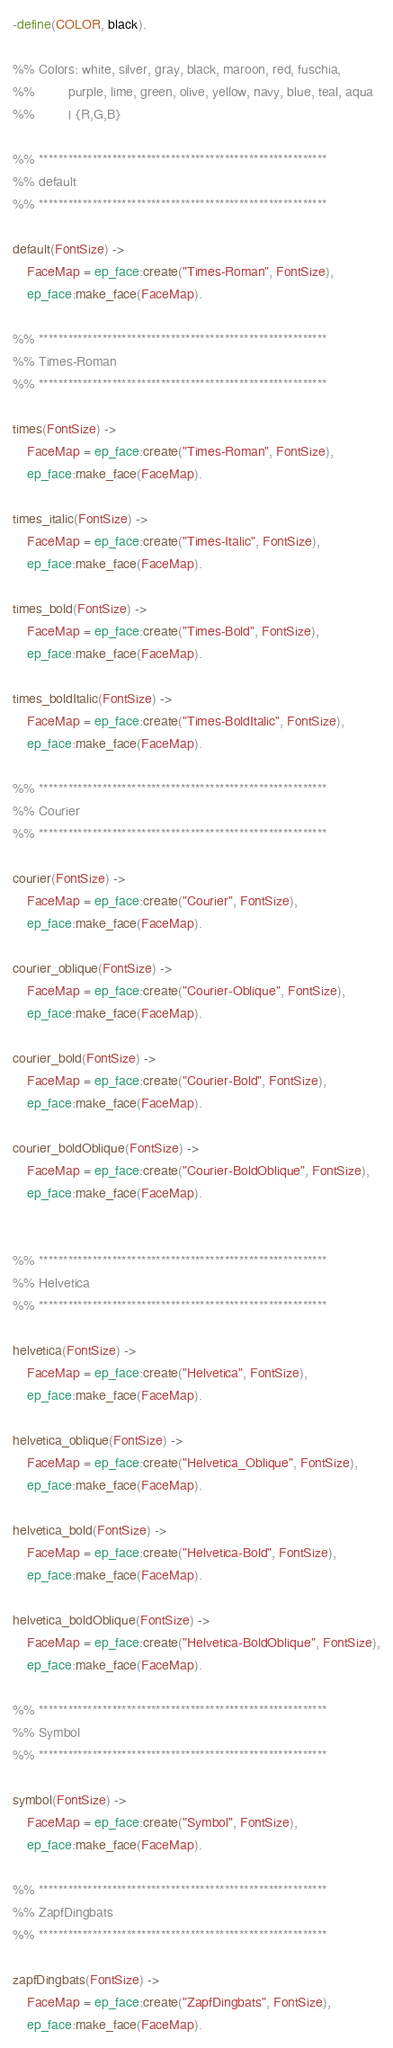Convert code to text. <code><loc_0><loc_0><loc_500><loc_500><_Erlang_>-define(COLOR, black).

%% Colors: white, silver, gray, black, maroon, red, fuschia,
%%         purple, lime, green, olive, yellow, navy, blue, teal, aqua 
%%         | {R,G,B}

%% ***********************************************************
%% default 
%% ***********************************************************

default(FontSize) ->
    FaceMap = ep_face:create("Times-Roman", FontSize),
    ep_face:make_face(FaceMap).

%% ***********************************************************
%% Times-Roman
%% ***********************************************************

times(FontSize) ->
    FaceMap = ep_face:create("Times-Roman", FontSize),
    ep_face:make_face(FaceMap).

times_italic(FontSize) ->
    FaceMap = ep_face:create("Times-Italic", FontSize),
    ep_face:make_face(FaceMap).

times_bold(FontSize) ->
    FaceMap = ep_face:create("Times-Bold", FontSize),
    ep_face:make_face(FaceMap).

times_boldItalic(FontSize) ->
    FaceMap = ep_face:create("Times-BoldItalic", FontSize),
    ep_face:make_face(FaceMap).

%% ***********************************************************
%% Courier 
%% ***********************************************************

courier(FontSize) ->
    FaceMap = ep_face:create("Courier", FontSize),
    ep_face:make_face(FaceMap).

courier_oblique(FontSize) ->
    FaceMap = ep_face:create("Courier-Oblique", FontSize),
    ep_face:make_face(FaceMap).

courier_bold(FontSize) ->
    FaceMap = ep_face:create("Courier-Bold", FontSize),
    ep_face:make_face(FaceMap).

courier_boldOblique(FontSize) ->
    FaceMap = ep_face:create("Courier-BoldOblique", FontSize),
    ep_face:make_face(FaceMap).


%% ***********************************************************
%% Helvetica 
%% ***********************************************************

helvetica(FontSize) ->
    FaceMap = ep_face:create("Helvetica", FontSize),
    ep_face:make_face(FaceMap).

helvetica_oblique(FontSize) ->
    FaceMap = ep_face:create("Helvetica_Oblique", FontSize),
    ep_face:make_face(FaceMap).

helvetica_bold(FontSize) ->
    FaceMap = ep_face:create("Helvetica-Bold", FontSize),
    ep_face:make_face(FaceMap).

helvetica_boldOblique(FontSize) ->
    FaceMap = ep_face:create("Helvetica-BoldOblique", FontSize),
    ep_face:make_face(FaceMap).

%% ***********************************************************
%% Symbol 
%% ***********************************************************

symbol(FontSize) ->
    FaceMap = ep_face:create("Symbol", FontSize),
    ep_face:make_face(FaceMap).

%% ***********************************************************
%% ZapfDingbats
%% ***********************************************************

zapfDingbats(FontSize) ->
    FaceMap = ep_face:create("ZapfDingbats", FontSize),
    ep_face:make_face(FaceMap).


</code> 